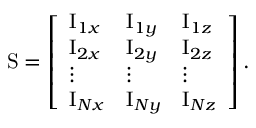<formula> <loc_0><loc_0><loc_500><loc_500>S = \left [ \begin{array} { l l l } { I _ { 1 x } } & { I _ { 1 y } } & { I _ { 1 z } } \\ { I _ { 2 x } } & { I _ { 2 y } } & { I _ { 2 z } } \\ { \vdots } & { \vdots } & { \vdots } \\ { I _ { N x } } & { I _ { N y } } & { I _ { N z } } \end{array} \right ] .</formula> 